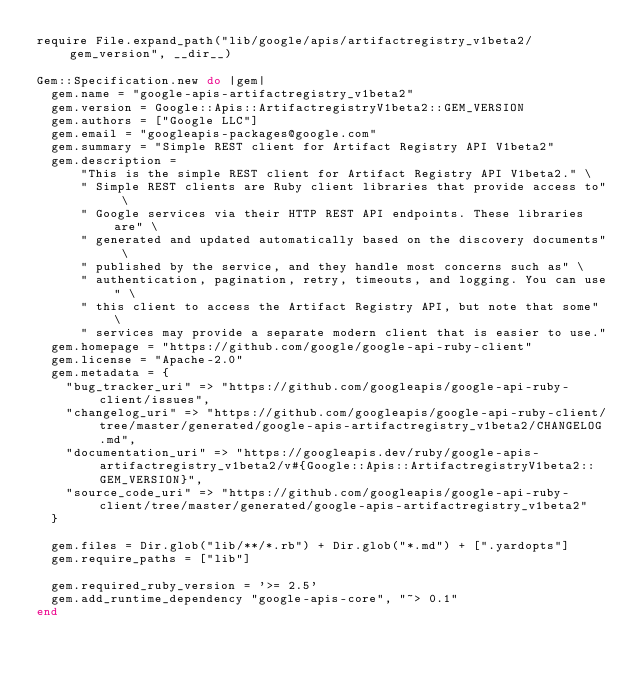Convert code to text. <code><loc_0><loc_0><loc_500><loc_500><_Ruby_>require File.expand_path("lib/google/apis/artifactregistry_v1beta2/gem_version", __dir__)

Gem::Specification.new do |gem|
  gem.name = "google-apis-artifactregistry_v1beta2"
  gem.version = Google::Apis::ArtifactregistryV1beta2::GEM_VERSION
  gem.authors = ["Google LLC"]
  gem.email = "googleapis-packages@google.com"
  gem.summary = "Simple REST client for Artifact Registry API V1beta2"
  gem.description =
      "This is the simple REST client for Artifact Registry API V1beta2." \
      " Simple REST clients are Ruby client libraries that provide access to" \
      " Google services via their HTTP REST API endpoints. These libraries are" \
      " generated and updated automatically based on the discovery documents" \
      " published by the service, and they handle most concerns such as" \
      " authentication, pagination, retry, timeouts, and logging. You can use" \
      " this client to access the Artifact Registry API, but note that some" \
      " services may provide a separate modern client that is easier to use."
  gem.homepage = "https://github.com/google/google-api-ruby-client"
  gem.license = "Apache-2.0"
  gem.metadata = {
    "bug_tracker_uri" => "https://github.com/googleapis/google-api-ruby-client/issues",
    "changelog_uri" => "https://github.com/googleapis/google-api-ruby-client/tree/master/generated/google-apis-artifactregistry_v1beta2/CHANGELOG.md",
    "documentation_uri" => "https://googleapis.dev/ruby/google-apis-artifactregistry_v1beta2/v#{Google::Apis::ArtifactregistryV1beta2::GEM_VERSION}",
    "source_code_uri" => "https://github.com/googleapis/google-api-ruby-client/tree/master/generated/google-apis-artifactregistry_v1beta2"
  }

  gem.files = Dir.glob("lib/**/*.rb") + Dir.glob("*.md") + [".yardopts"]
  gem.require_paths = ["lib"]

  gem.required_ruby_version = '>= 2.5'
  gem.add_runtime_dependency "google-apis-core", "~> 0.1"
end
</code> 